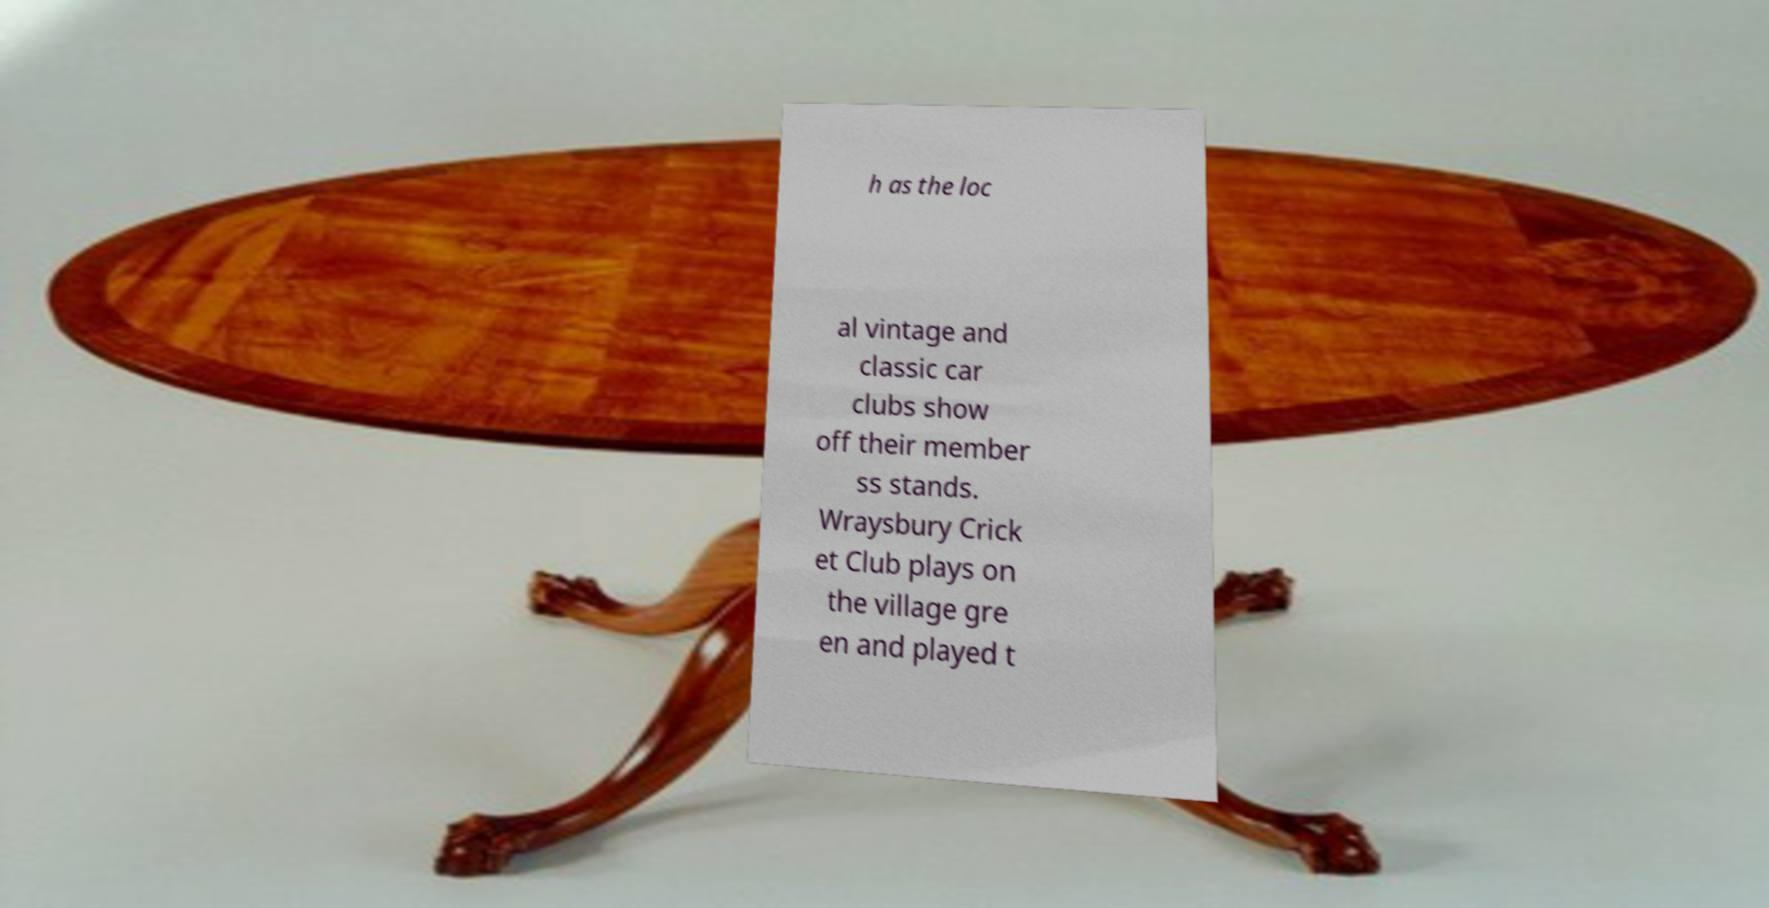I need the written content from this picture converted into text. Can you do that? h as the loc al vintage and classic car clubs show off their member ss stands. Wraysbury Crick et Club plays on the village gre en and played t 